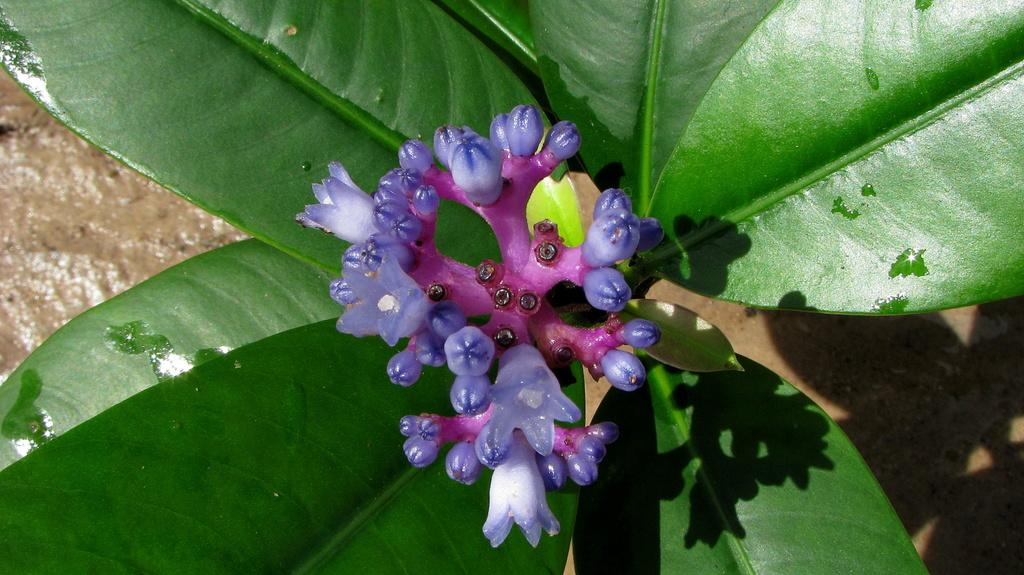What type of plants can be seen in the image? There are flowers in the image. What color are the flowers? The flowers are pale purple in color. What else can be seen in the image besides the flowers? There are leaves visible in the image. What is the ground made of in the image? There is mud visible in the image. How much money is being exchanged between the flowers in the image? There is no money being exchanged in the image; it features flowers, leaves, and mud. What is the reason for the flowers being in the mud in the image? The image does not provide any information about the reason for the flowers being in the mud; it simply shows them in that condition. 